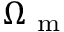Convert formula to latex. <formula><loc_0><loc_0><loc_500><loc_500>\Omega _ { m }</formula> 